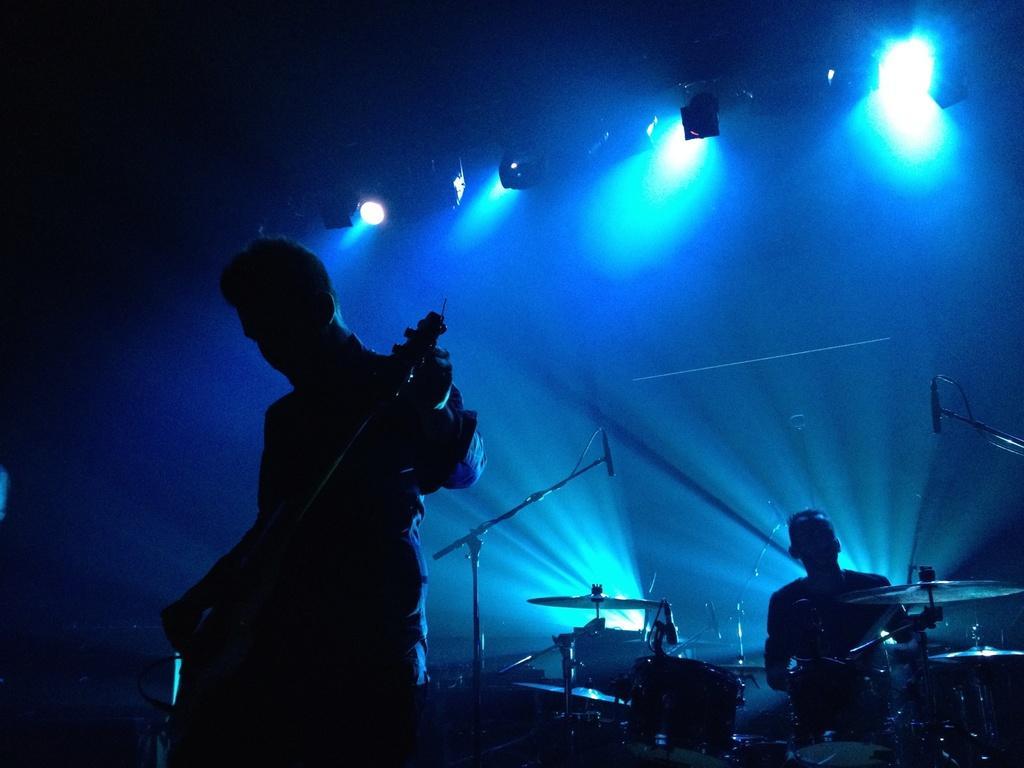Please provide a concise description of this image. In this image, we can see a person is holding a musical instrument. Background there is a dark view. Here we can see few lights. Right side bottom, we can see a person and musical instrument. 